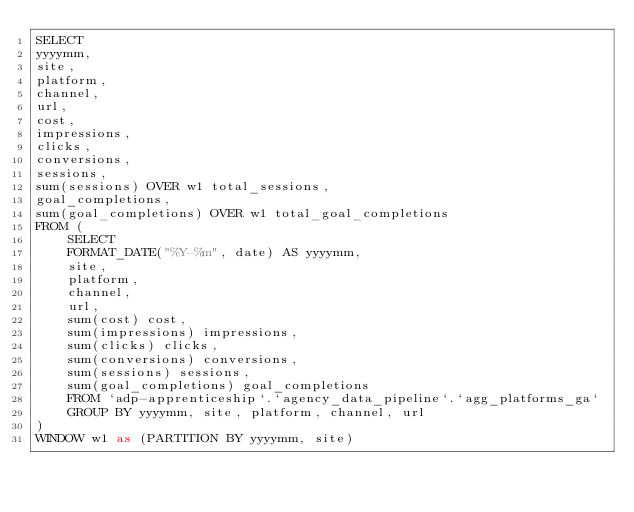<code> <loc_0><loc_0><loc_500><loc_500><_SQL_>SELECT
yyyymm, 
site,
platform,
channel, 
url,
cost,
impressions,
clicks,
conversions,
sessions,
sum(sessions) OVER w1 total_sessions,
goal_completions,
sum(goal_completions) OVER w1 total_goal_completions
FROM (
    SELECT 
    FORMAT_DATE("%Y-%m", date) AS yyyymm,
    site,
    platform,
    channel, 
    url,
    sum(cost) cost,
    sum(impressions) impressions,
    sum(clicks) clicks,
    sum(conversions) conversions,
    sum(sessions) sessions,
    sum(goal_completions) goal_completions
    FROM `adp-apprenticeship`.`agency_data_pipeline`.`agg_platforms_ga`
    GROUP BY yyyymm, site, platform, channel, url
)
WINDOW w1 as (PARTITION BY yyyymm, site)</code> 